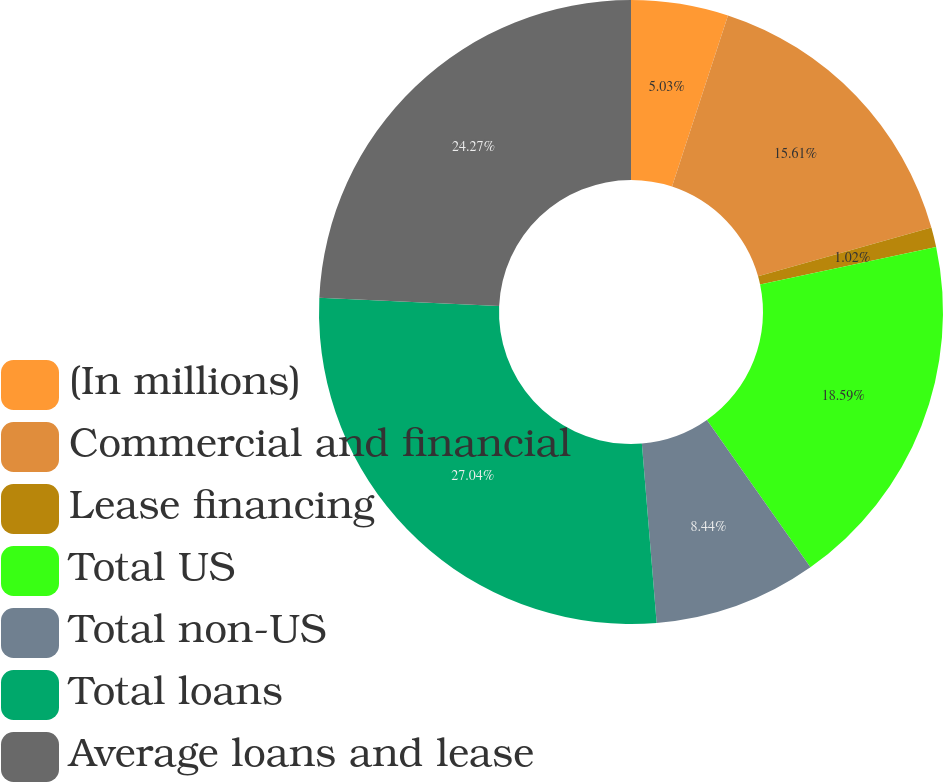<chart> <loc_0><loc_0><loc_500><loc_500><pie_chart><fcel>(In millions)<fcel>Commercial and financial<fcel>Lease financing<fcel>Total US<fcel>Total non-US<fcel>Total loans<fcel>Average loans and lease<nl><fcel>5.03%<fcel>15.61%<fcel>1.02%<fcel>18.59%<fcel>8.44%<fcel>27.04%<fcel>24.27%<nl></chart> 